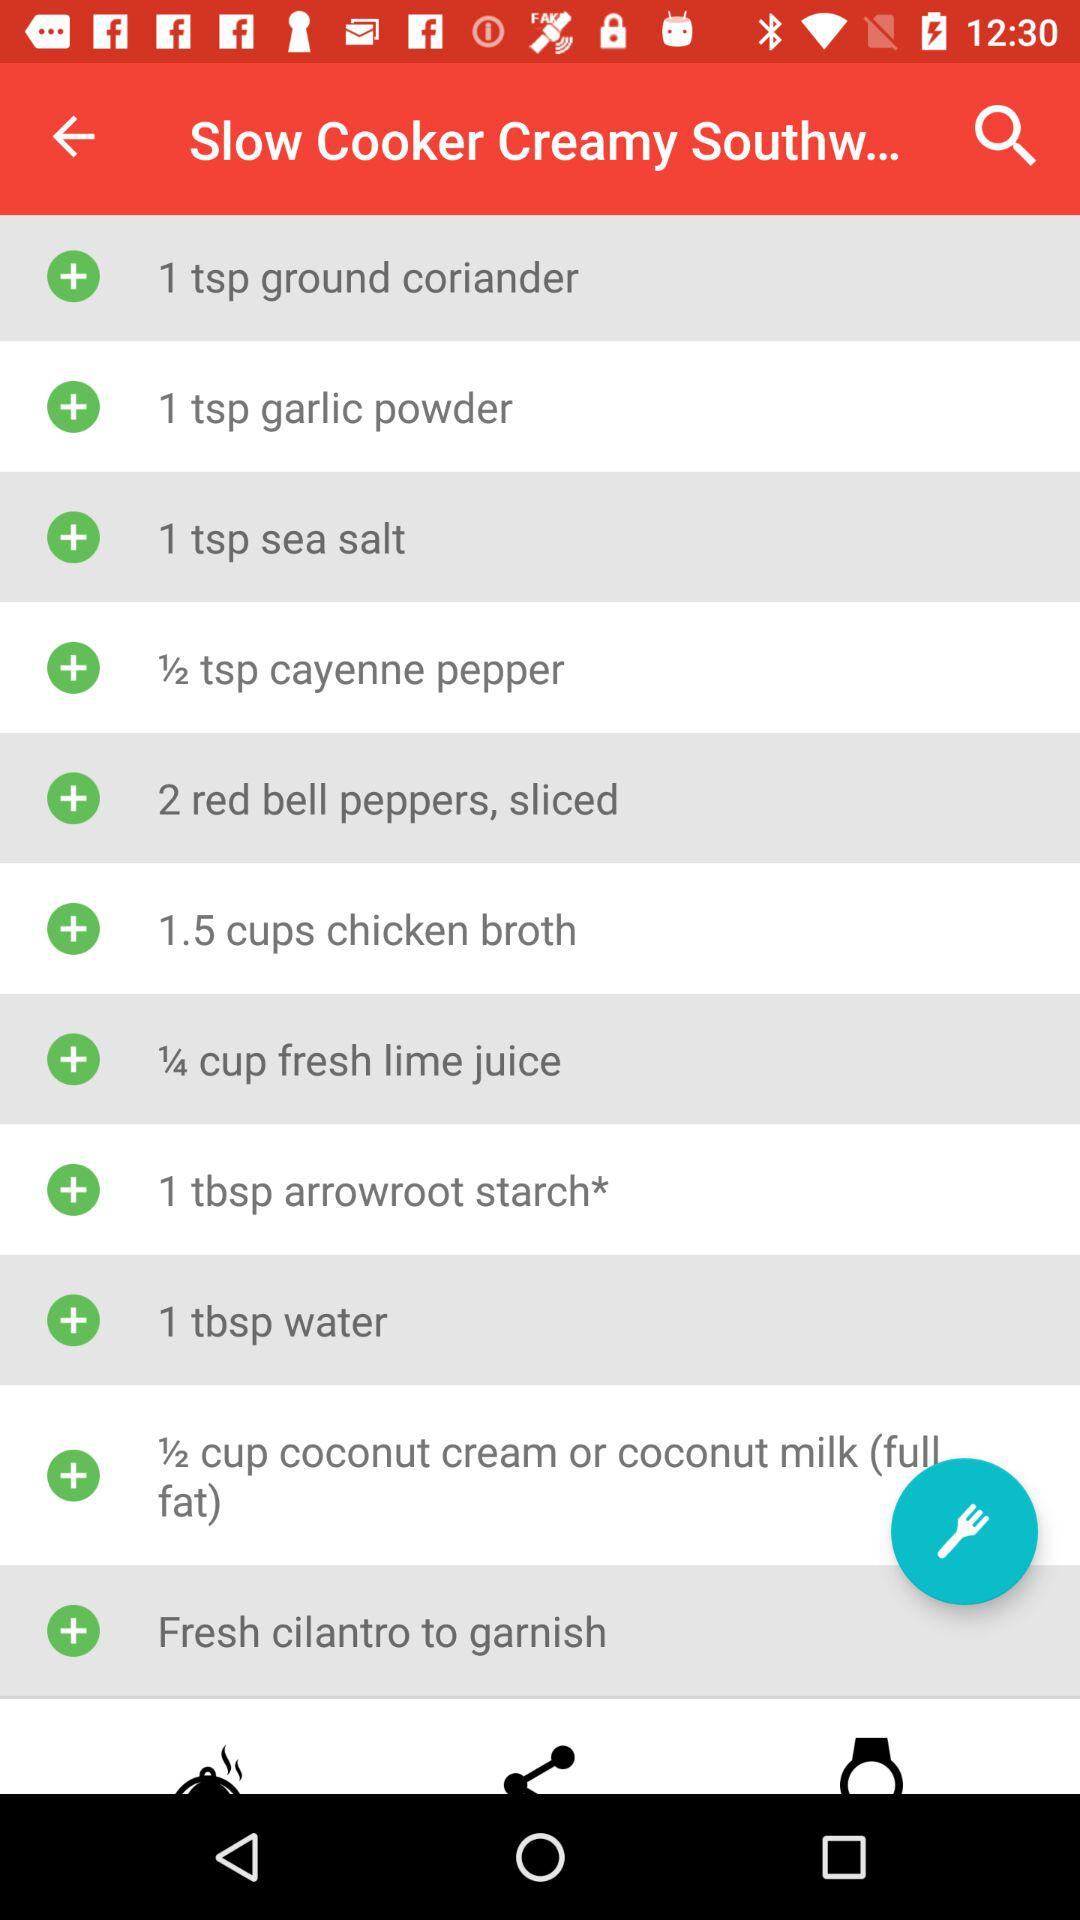How many bell peppers are needed? The number of bell peppers that are needed is 2. 